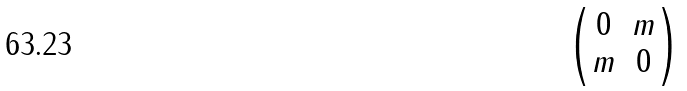Convert formula to latex. <formula><loc_0><loc_0><loc_500><loc_500>\begin{pmatrix} 0 & m \\ m & 0 \end{pmatrix}</formula> 